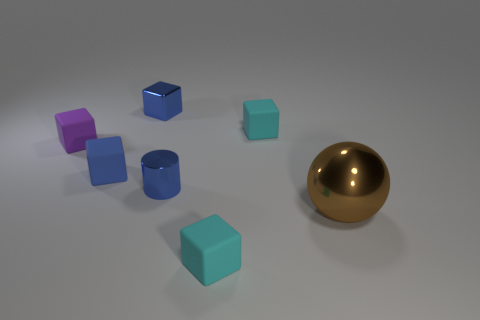There is a small cyan object that is behind the small cube that is in front of the metallic object that is to the right of the tiny shiny cylinder; what shape is it?
Offer a terse response. Cube. Are there more small purple things behind the purple object than balls?
Your answer should be very brief. No. Is there a tiny yellow thing that has the same shape as the large brown metallic thing?
Your answer should be compact. No. Does the large ball have the same material as the small cube that is in front of the tiny blue metallic cylinder?
Keep it short and to the point. No. What is the color of the shiny sphere?
Your response must be concise. Brown. There is a tiny blue metal cylinder that is to the left of the small cyan rubber cube in front of the small metal cylinder; how many blue shiny things are behind it?
Offer a terse response. 1. There is a brown metallic thing; are there any blue blocks in front of it?
Ensure brevity in your answer.  No. What number of blocks are the same material as the big thing?
Provide a short and direct response. 1. How many things are either balls or cyan matte cubes?
Your response must be concise. 3. Are there any brown metal objects?
Give a very brief answer. Yes. 